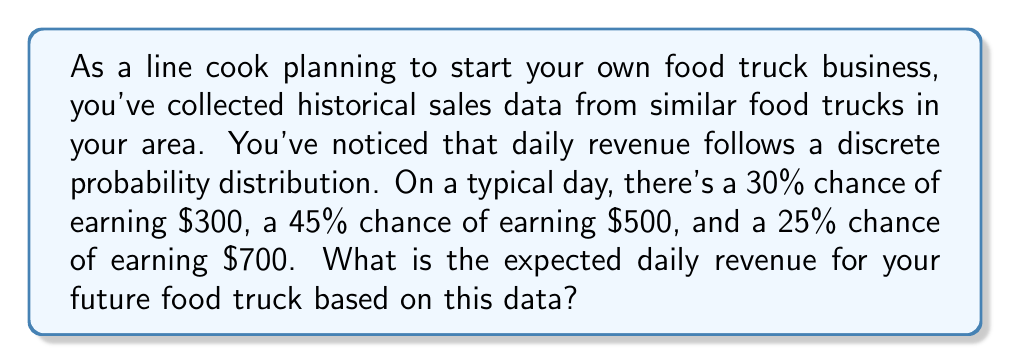Can you solve this math problem? To solve this problem, we need to calculate the expected value of the daily revenue. The expected value of a discrete random variable is the sum of each possible outcome multiplied by its probability.

Let's define our random variable $X$ as the daily revenue.

We have the following probability distribution:
$P(X = 300) = 0.30$
$P(X = 500) = 0.45$
$P(X = 700) = 0.25$

The formula for expected value is:

$$E(X) = \sum_{i=1}^{n} x_i \cdot P(X = x_i)$$

Where $x_i$ are the possible values of $X$, and $P(X = x_i)$ is the probability of $X$ taking on the value $x_i$.

Let's calculate:

$$\begin{align*}
E(X) &= 300 \cdot 0.30 + 500 \cdot 0.45 + 700 \cdot 0.25 \\
&= 90 + 225 + 175 \\
&= 490
\end{align*}$$

Therefore, the expected daily revenue is $490.
Answer: $490 